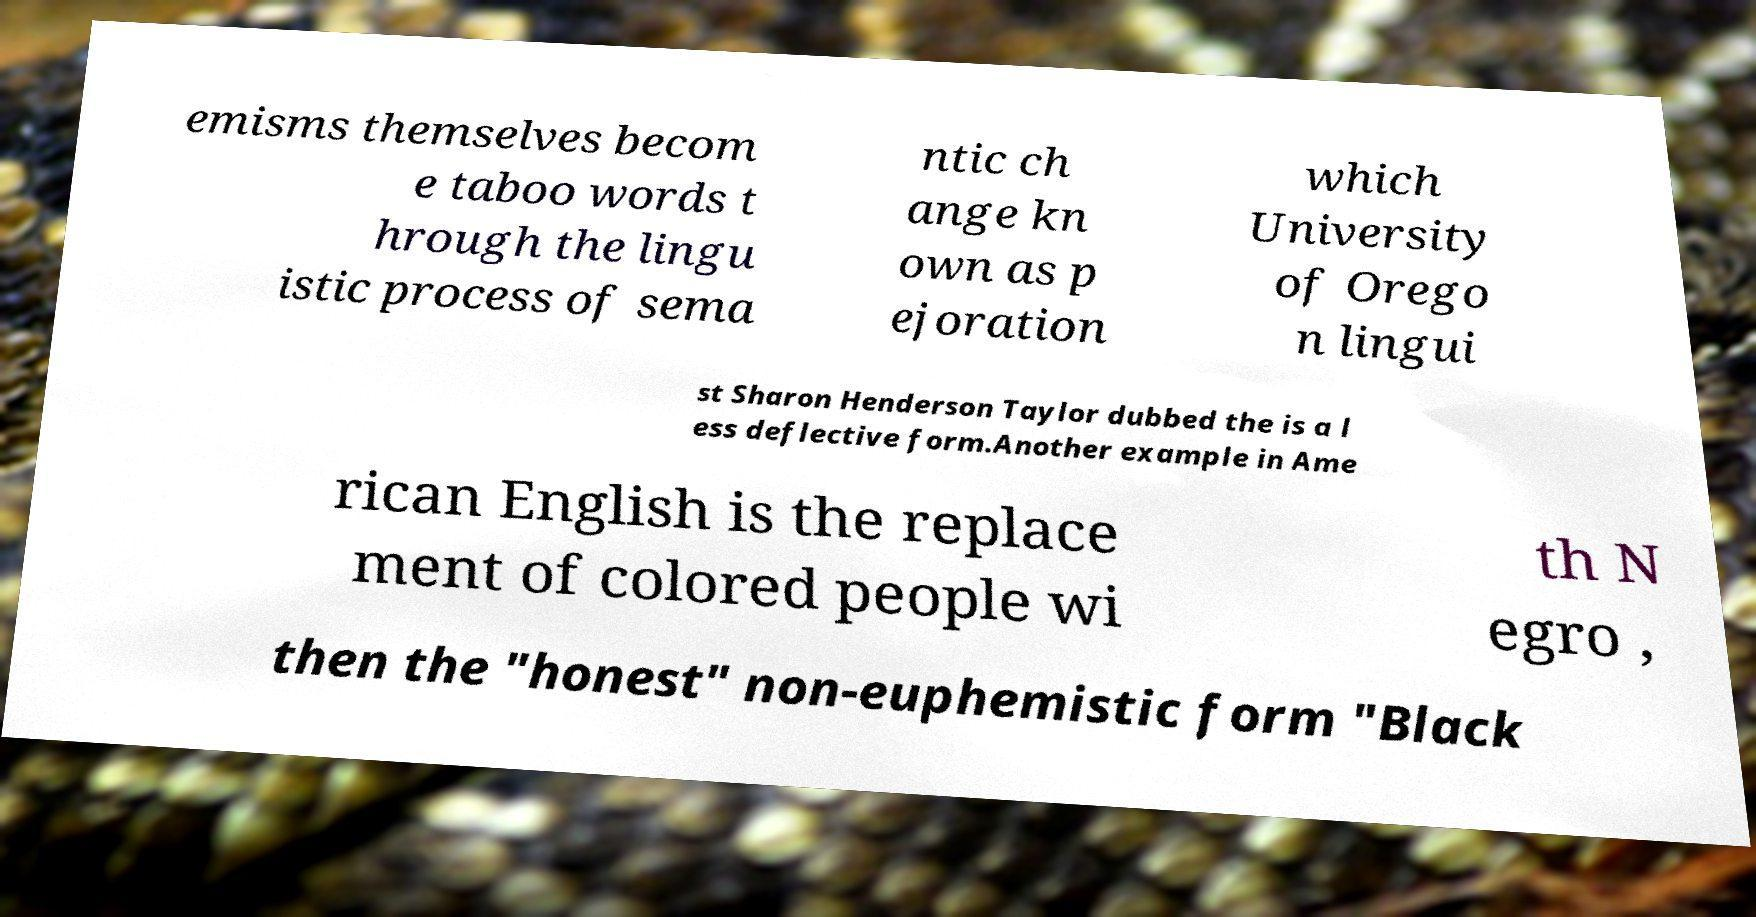For documentation purposes, I need the text within this image transcribed. Could you provide that? emisms themselves becom e taboo words t hrough the lingu istic process of sema ntic ch ange kn own as p ejoration which University of Orego n lingui st Sharon Henderson Taylor dubbed the is a l ess deflective form.Another example in Ame rican English is the replace ment of colored people wi th N egro , then the "honest" non-euphemistic form "Black 